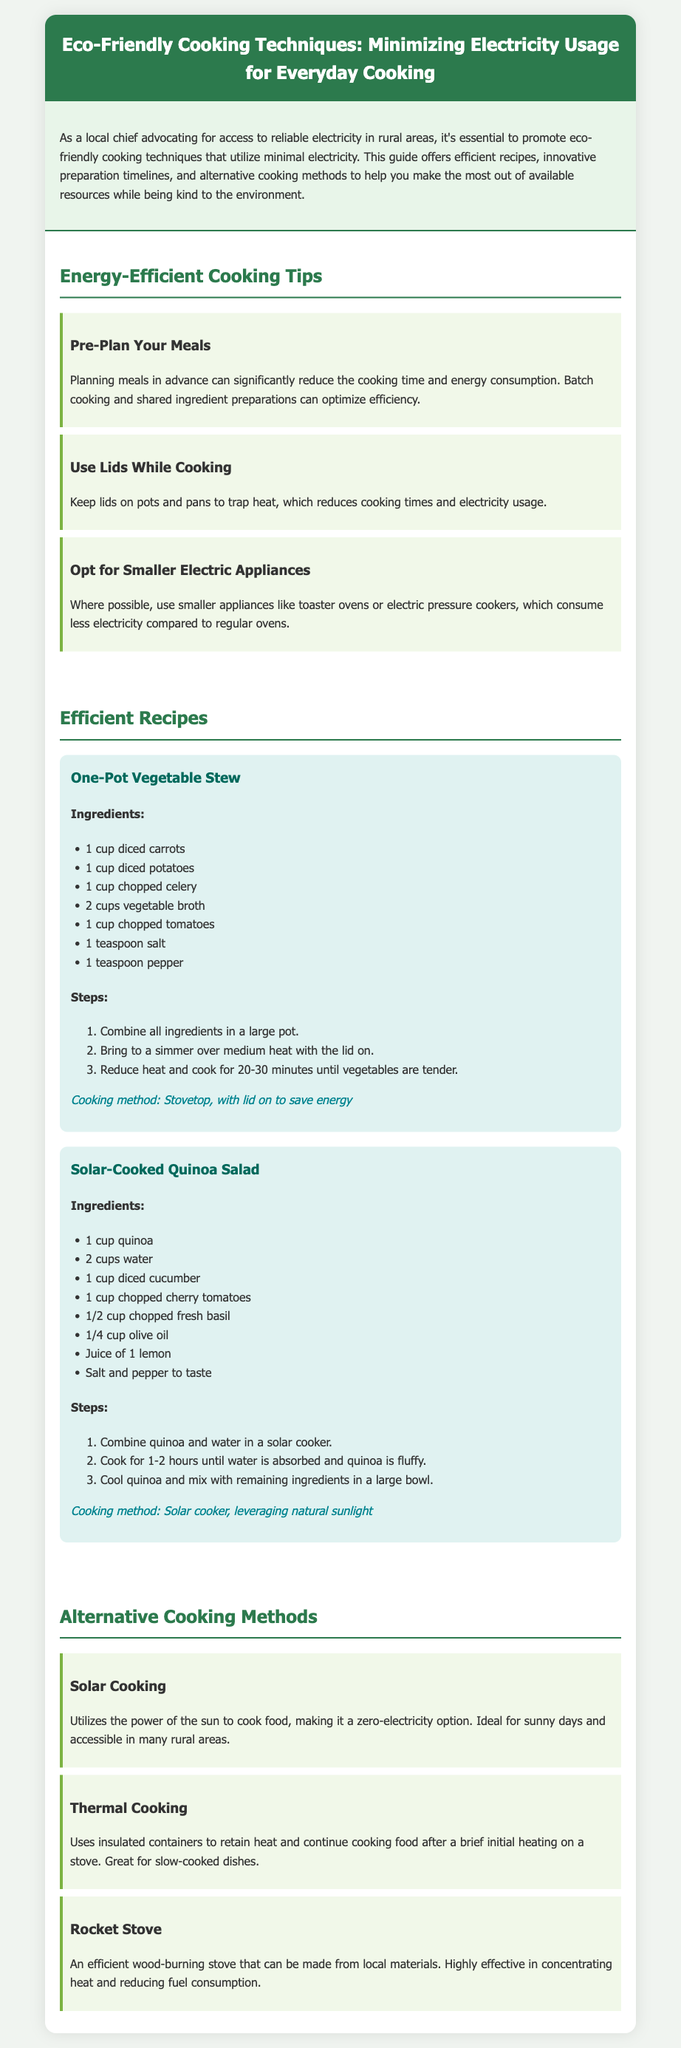What is the title of the document? The title is provided in the header of the document, which states "Eco-Friendly Cooking Techniques: Minimizing Electricity Usage for Everyday Cooking."
Answer: Eco-Friendly Cooking Techniques: Minimizing Electricity Usage for Everyday Cooking How many recipes are included in the document? The document lists two specific recipes under the "Efficient Recipes" section.
Answer: Two What cooking method is used for the One-Pot Vegetable Stew? The cooking method for the One-Pot Vegetable Stew is stated as "Stovetop, with lid on to save energy."
Answer: Stovetop What alternative cooking method uses insulated containers? The document describes "Thermal Cooking" as an alternative cooking method that uses insulated containers.
Answer: Thermal Cooking Which recipe takes advantage of natural sunlight? The recipe "Solar-Cooked Quinoa Salad" utilizes natural sunlight for cooking.
Answer: Solar-Cooked Quinoa Salad What ingredient is common to both recipes? Both recipes contain the ingredient "salt" as listed in their ingredients section.
Answer: Salt What is one tip for reducing cooking time? One of the tips suggests "Pre-Plan Your Meals" to significantly reduce cooking time and energy consumption.
Answer: Pre-Plan Your Meals How long should the quinoa be cooked in a solar cooker? The document specifies that the quinoa should be cooked for "1-2 hours until water is absorbed and quinoa is fluffy."
Answer: 1-2 hours 